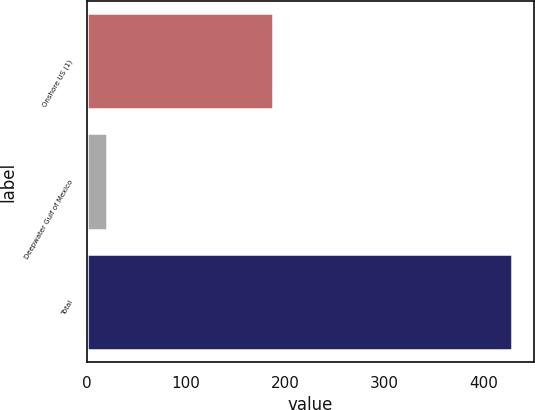<chart> <loc_0><loc_0><loc_500><loc_500><bar_chart><fcel>Onshore US (1)<fcel>Deepwater Gulf of Mexico<fcel>Total<nl><fcel>188<fcel>20<fcel>429<nl></chart> 